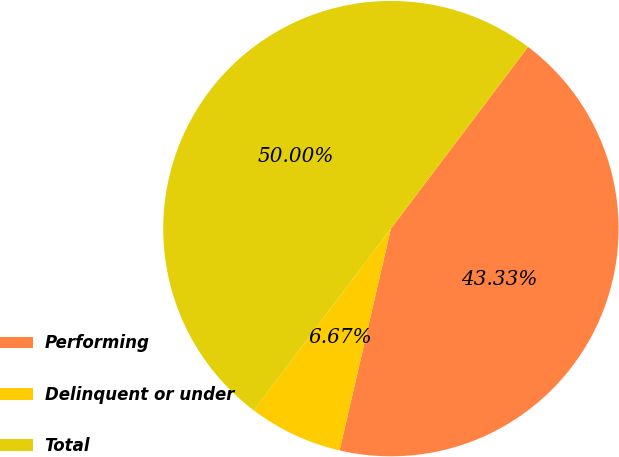Convert chart to OTSL. <chart><loc_0><loc_0><loc_500><loc_500><pie_chart><fcel>Performing<fcel>Delinquent or under<fcel>Total<nl><fcel>43.33%<fcel>6.67%<fcel>50.0%<nl></chart> 